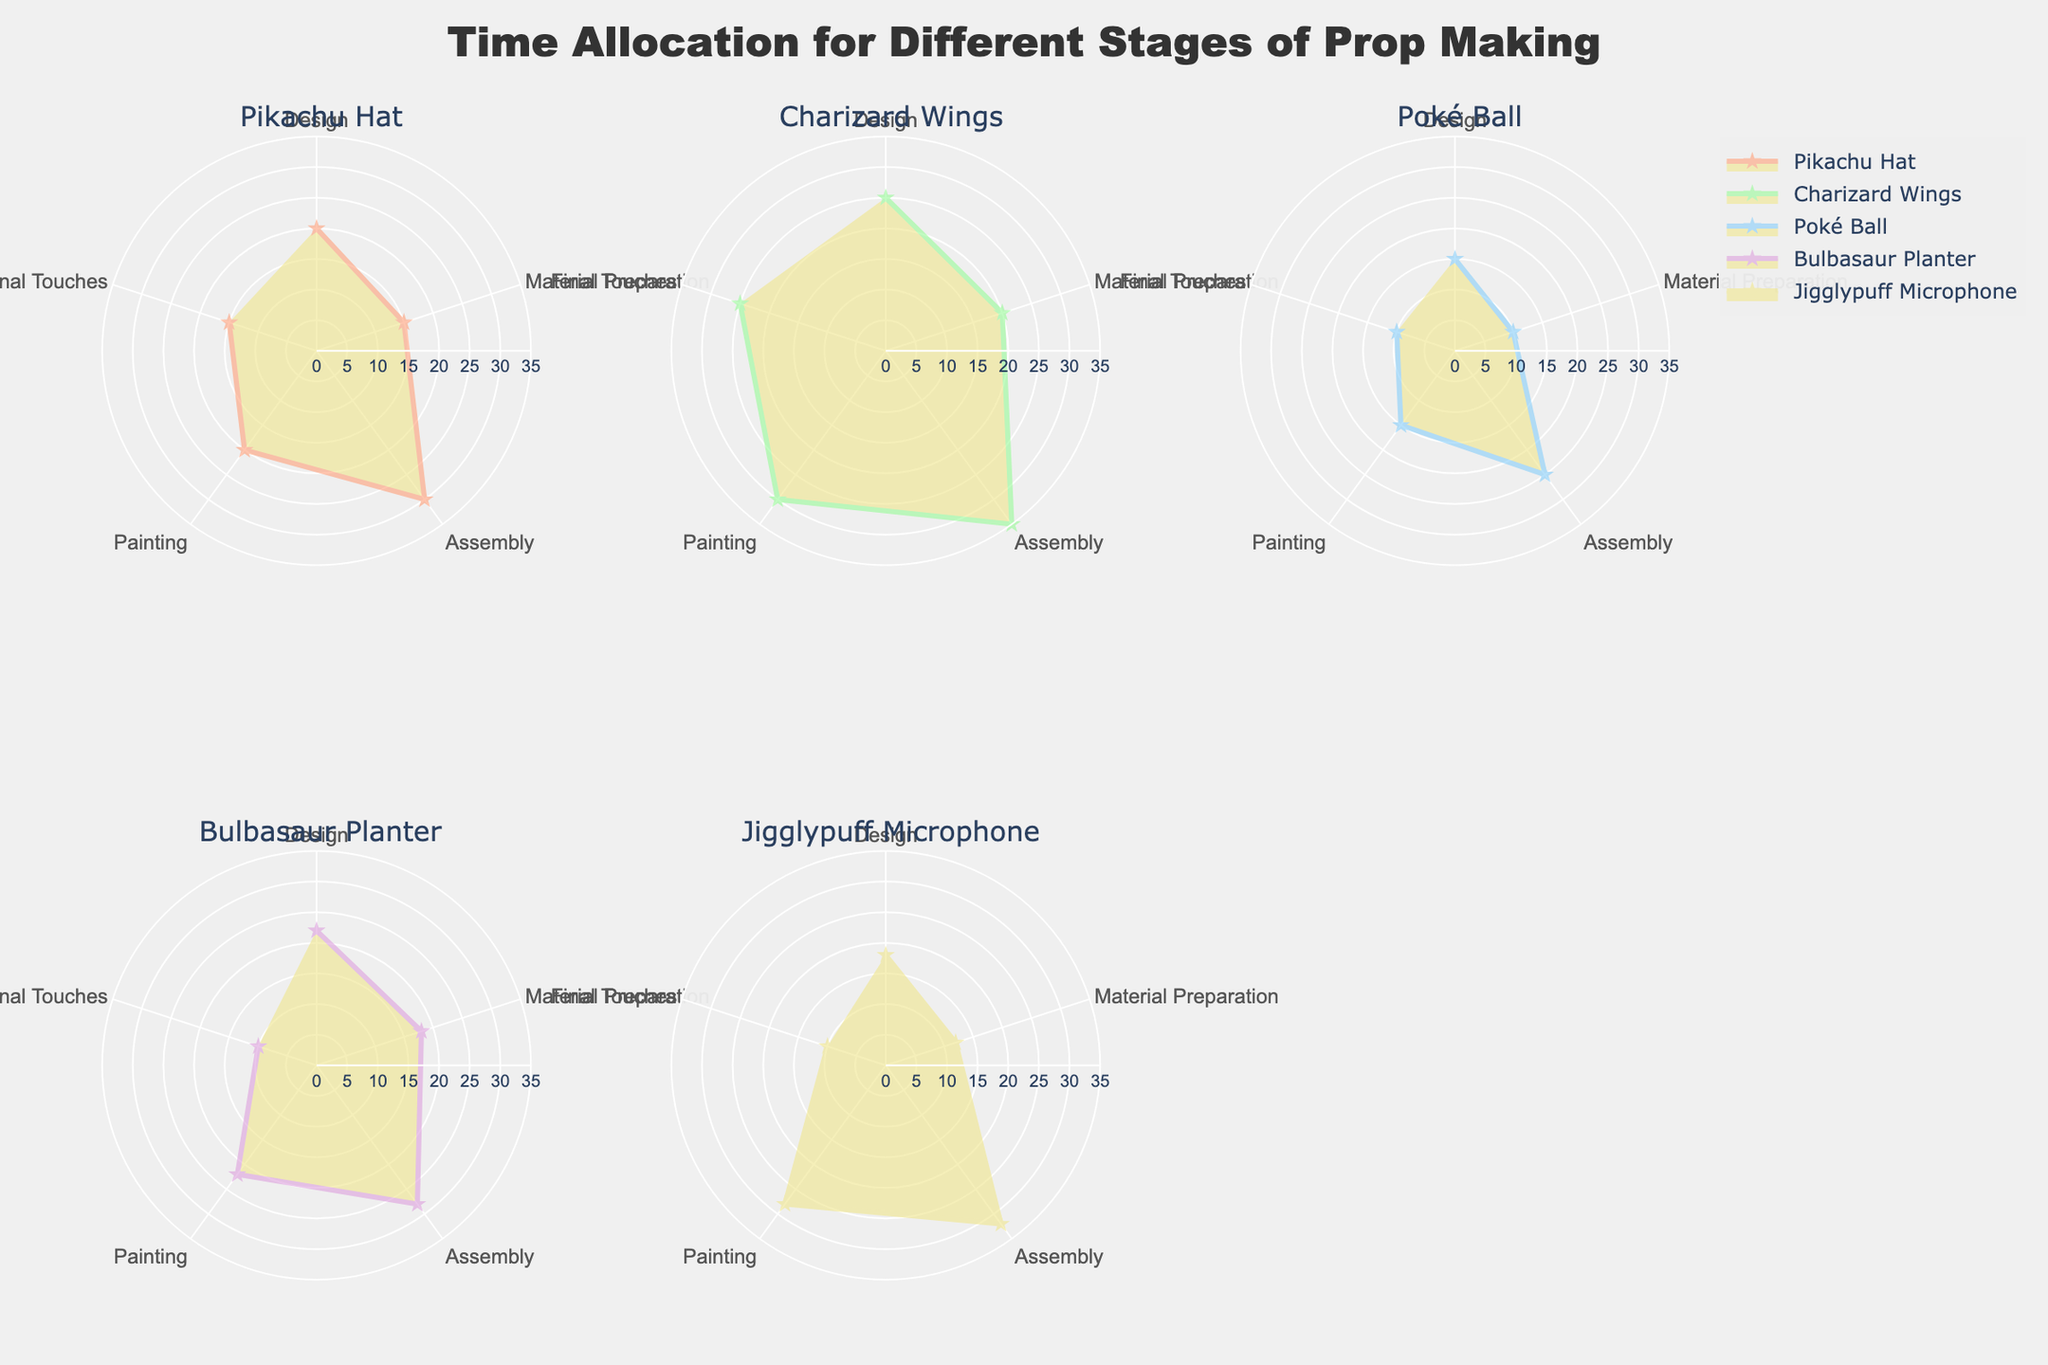What's the title of the figure? The main title is usually displayed prominently at the top of the figure. By reading this title, you can understand the main focus of the data presented.
Answer: Time Allocation for Different Stages of Prop Making How many stages are considered for each prop? The figure presents the data in radar charts, which often use a radial axis to show different categories. By counting the number of categories, we can determine how many stages are considered.
Answer: 5 Which prop requires the most time for Assembly? By observing the radar charts, specifically the section labeled "Assembly," we can identify which chart has the highest value.
Answer: Charizard Wings Which prop requires the least amount of time for Final Touches? Look at the 'Final Touches' section across all radar charts to find the smallest value.
Answer: Jigglypuff Microphone What is the average time spent on Painting across all props? To find the average time, we'll first add the values for Painting from each prop and then divide by the number of props: (20 + 30 + 15 + 22 + 28) / 5. So, the average is 115 / 5.
Answer: 23 Which stages take up the majority of time for the Pikachu Hat? By examining the radar chart for the Pikachu Hat, we can see which stages have the largest values.
Answer: Assembly and Painting Compare the total time spent on Material Preparation and Final Touches for Bulbasaur Planter. Which one is greater? Sum the values for Material Preparation (18) and Final Touches (10) for Bulbasaur Planter. Material Preparation is 18, and Final Touches is 10. Since 18 > 10, Material Preparation is greater.
Answer: Material Preparation What is the difference in the time allocated for Design between Jigglypuff Microphone and Poké Ball? Find the values for Design in Jigglypuff Microphone (18) and Poké Ball (15), then subtract the smaller value from the larger one: 18 - 15.
Answer: 3 Which prop shows the greatest variability in time allocation across different stages? By identifying the radar chart with the most significant differences between the maximum and minimum values, we end up with the Charizard Wings prop, showing a range from a minimum of 20 (Material Preparation) to a maximum of 35 (Assembly).
Answer: Charizard Wings How many radar charts are present in the figure? Each prop is represented by a separate radar chart; we can count the number of different prop names and hence the number of charts.
Answer: 5 